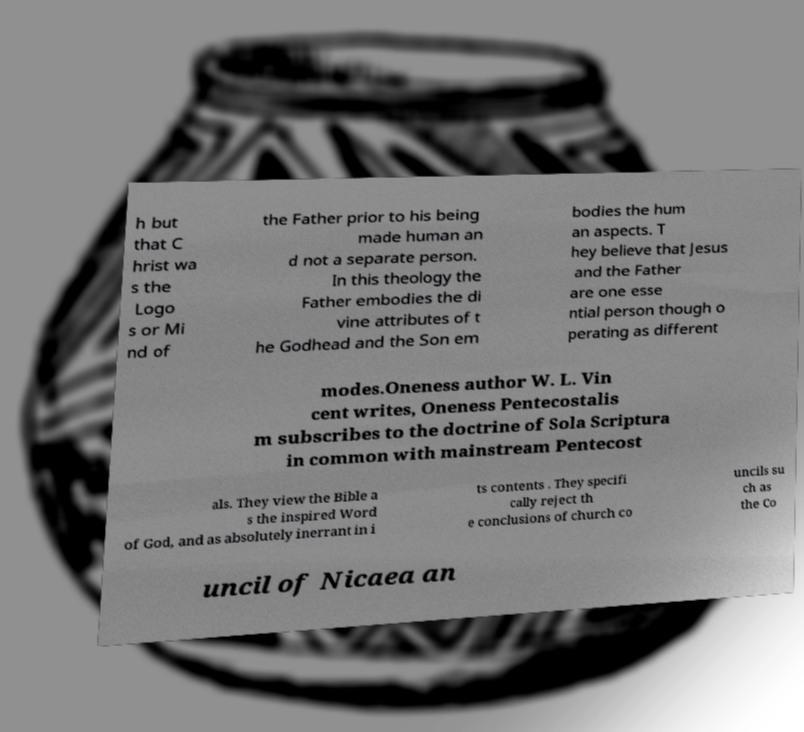Could you assist in decoding the text presented in this image and type it out clearly? h but that C hrist wa s the Logo s or Mi nd of the Father prior to his being made human an d not a separate person. In this theology the Father embodies the di vine attributes of t he Godhead and the Son em bodies the hum an aspects. T hey believe that Jesus and the Father are one esse ntial person though o perating as different modes.Oneness author W. L. Vin cent writes, Oneness Pentecostalis m subscribes to the doctrine of Sola Scriptura in common with mainstream Pentecost als. They view the Bible a s the inspired Word of God, and as absolutely inerrant in i ts contents . They specifi cally reject th e conclusions of church co uncils su ch as the Co uncil of Nicaea an 